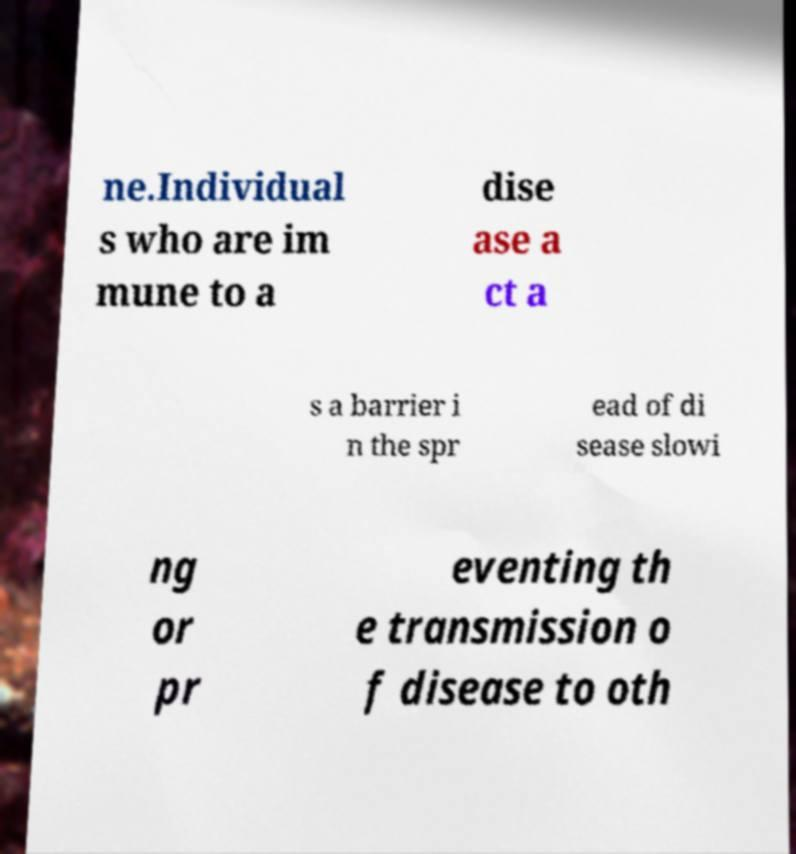Please identify and transcribe the text found in this image. ne.Individual s who are im mune to a dise ase a ct a s a barrier i n the spr ead of di sease slowi ng or pr eventing th e transmission o f disease to oth 